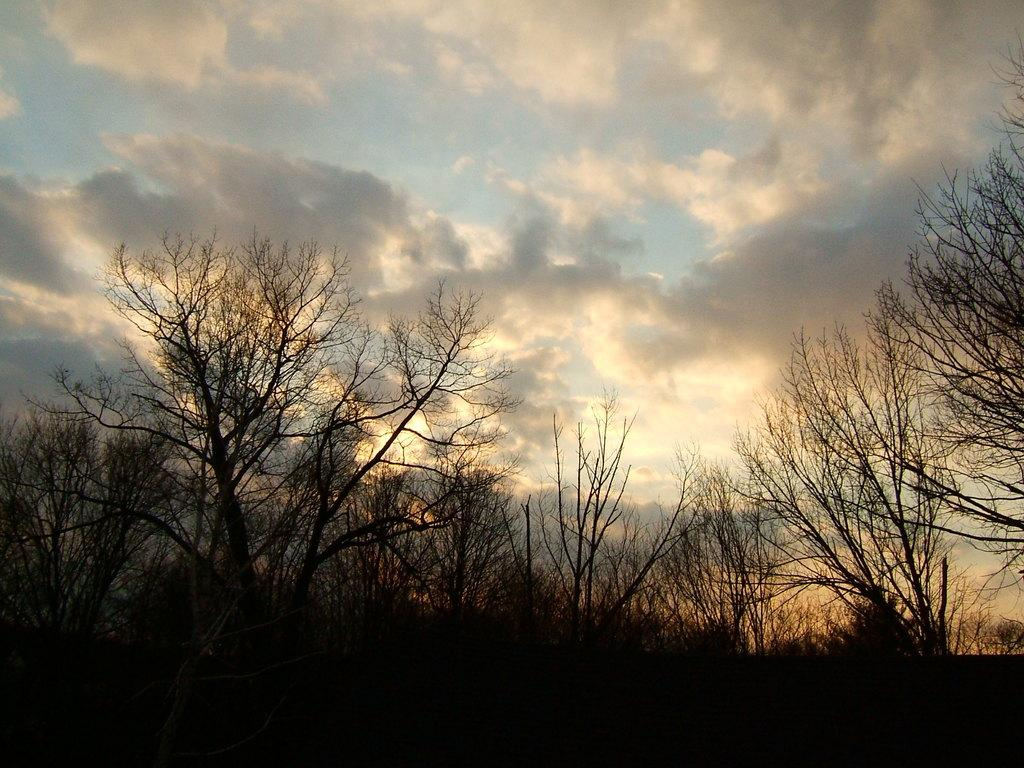What type of view is shown in the image? The image is an outside view. What can be seen at the bottom of the image? There are many trees at the bottom of the image. What is visible at the top of the image? The sky is visible at the top of the image. What can be observed in the sky? Clouds are present in the sky. Where is the beggar standing in the image? There is no beggar present in the image. What type of glue is being used to stick the air to the trees in the image? There is no air or glue present in the image; it features an outside view with trees and a sky. 